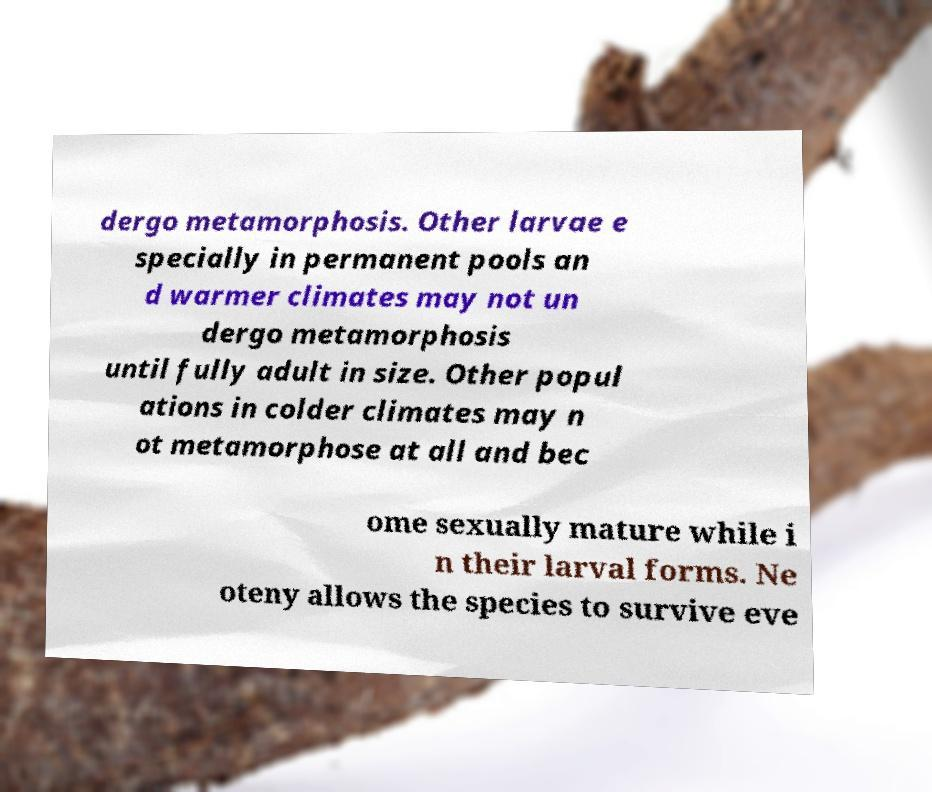Could you assist in decoding the text presented in this image and type it out clearly? dergo metamorphosis. Other larvae e specially in permanent pools an d warmer climates may not un dergo metamorphosis until fully adult in size. Other popul ations in colder climates may n ot metamorphose at all and bec ome sexually mature while i n their larval forms. Ne oteny allows the species to survive eve 